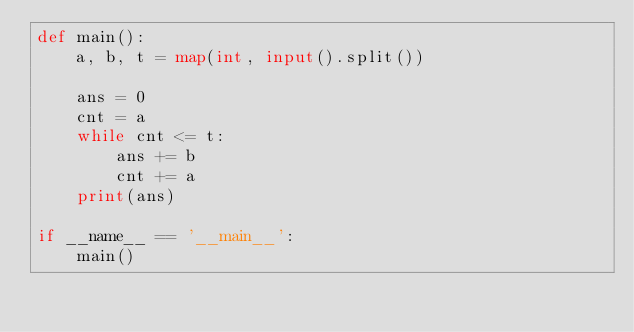<code> <loc_0><loc_0><loc_500><loc_500><_Python_>def main():
    a, b, t = map(int, input().split())

    ans = 0
    cnt = a
    while cnt <= t:
        ans += b
        cnt += a
    print(ans)

if __name__ == '__main__':
    main()
</code> 